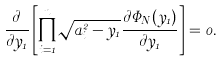<formula> <loc_0><loc_0><loc_500><loc_500>\frac { \partial } { \partial y _ { 1 } } \left [ \prod _ { i = 1 } ^ { n } \sqrt { a _ { i } ^ { 2 } - y _ { 1 } } \frac { \partial \Phi _ { N } ( y _ { 1 } ) } { \partial y _ { 1 } } \right ] = 0 .</formula> 